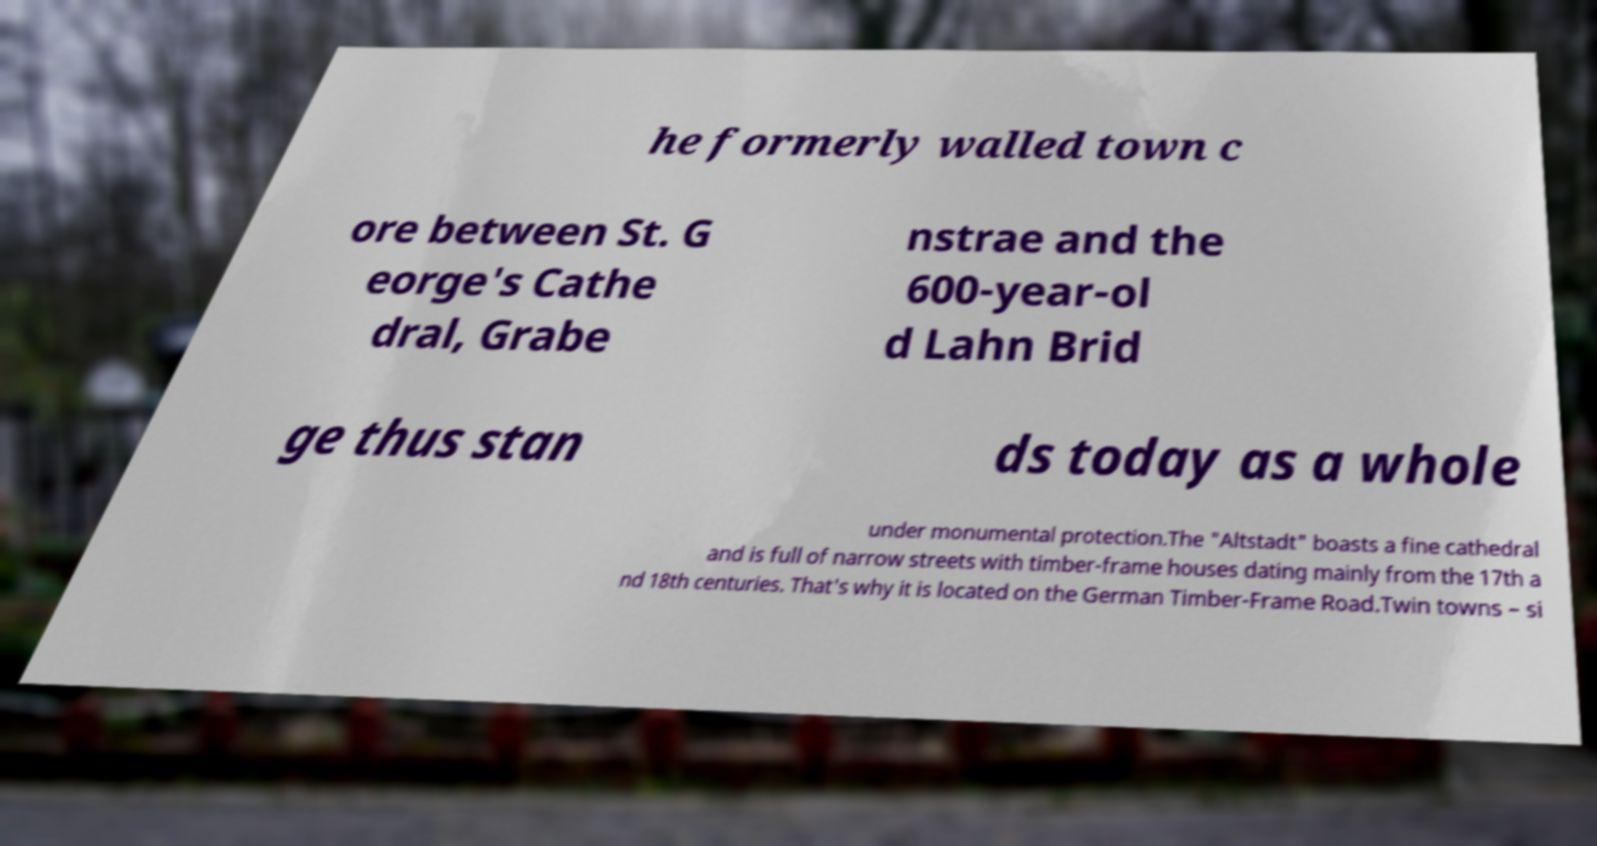Please read and relay the text visible in this image. What does it say? he formerly walled town c ore between St. G eorge's Cathe dral, Grabe nstrae and the 600-year-ol d Lahn Brid ge thus stan ds today as a whole under monumental protection.The "Altstadt" boasts a fine cathedral and is full of narrow streets with timber-frame houses dating mainly from the 17th a nd 18th centuries. That's why it is located on the German Timber-Frame Road.Twin towns – si 